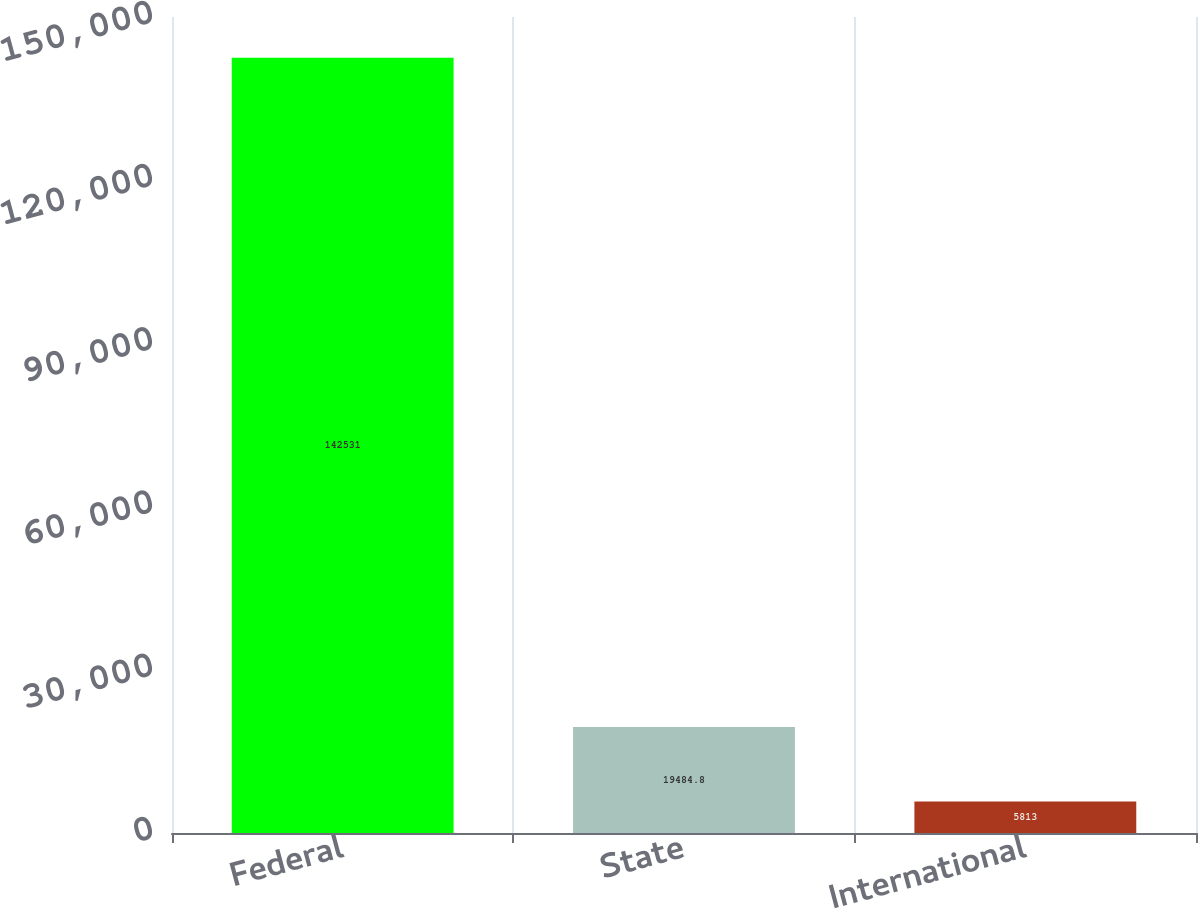Convert chart to OTSL. <chart><loc_0><loc_0><loc_500><loc_500><bar_chart><fcel>Federal<fcel>State<fcel>International<nl><fcel>142531<fcel>19484.8<fcel>5813<nl></chart> 